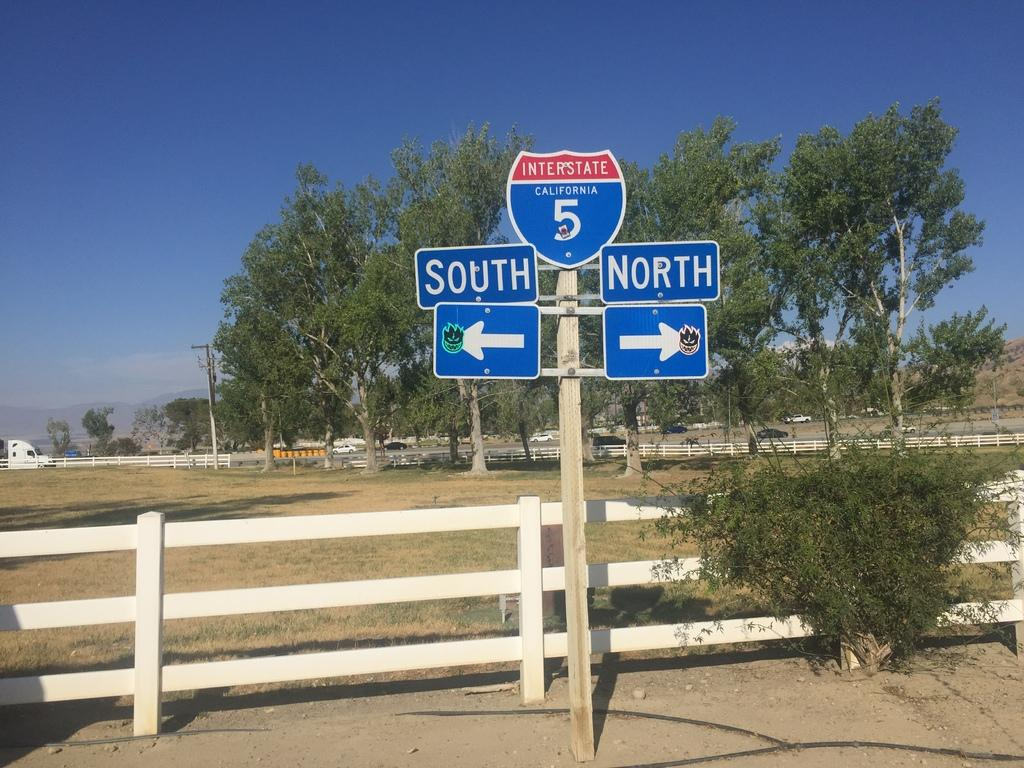<image>
Relay a brief, clear account of the picture shown. a sign for Interstate 5 North and South by a rural fence 